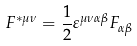Convert formula to latex. <formula><loc_0><loc_0><loc_500><loc_500>F ^ { * \mu \nu } = \frac { 1 } { 2 } \varepsilon ^ { \mu \nu \alpha \beta } F _ { \alpha \beta }</formula> 